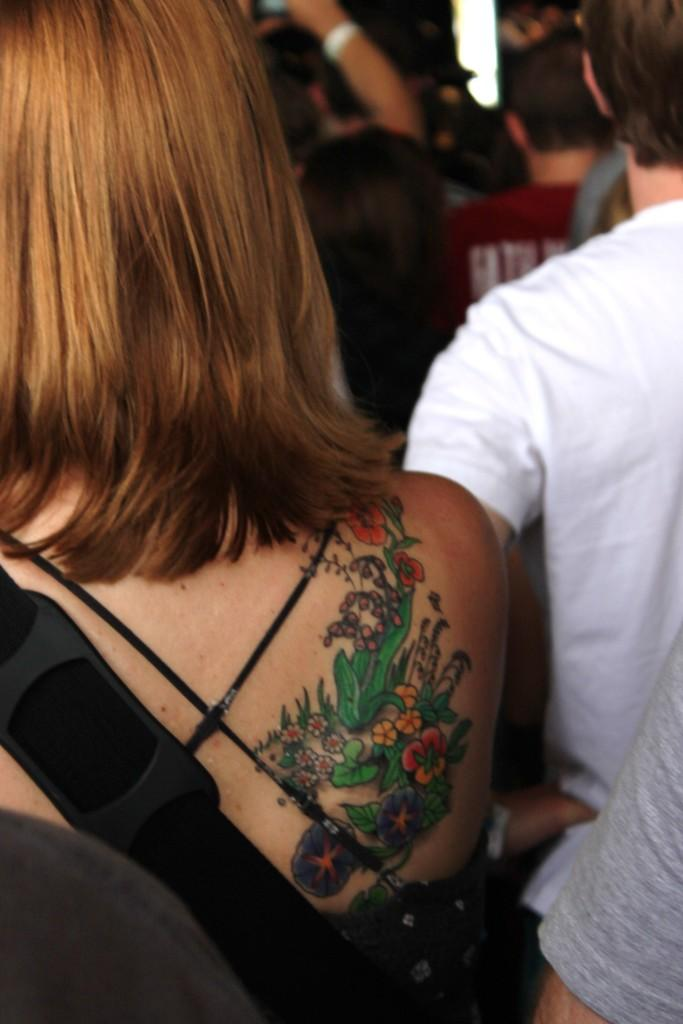What is a notable feature of the woman in the image? The woman in the image has a tattoo. Can you describe the overall scene in the image? There is a group of people in the image. What type of noise does the deer make in the image? There is no deer present in the image, so it is not possible to determine what noise it might make. 